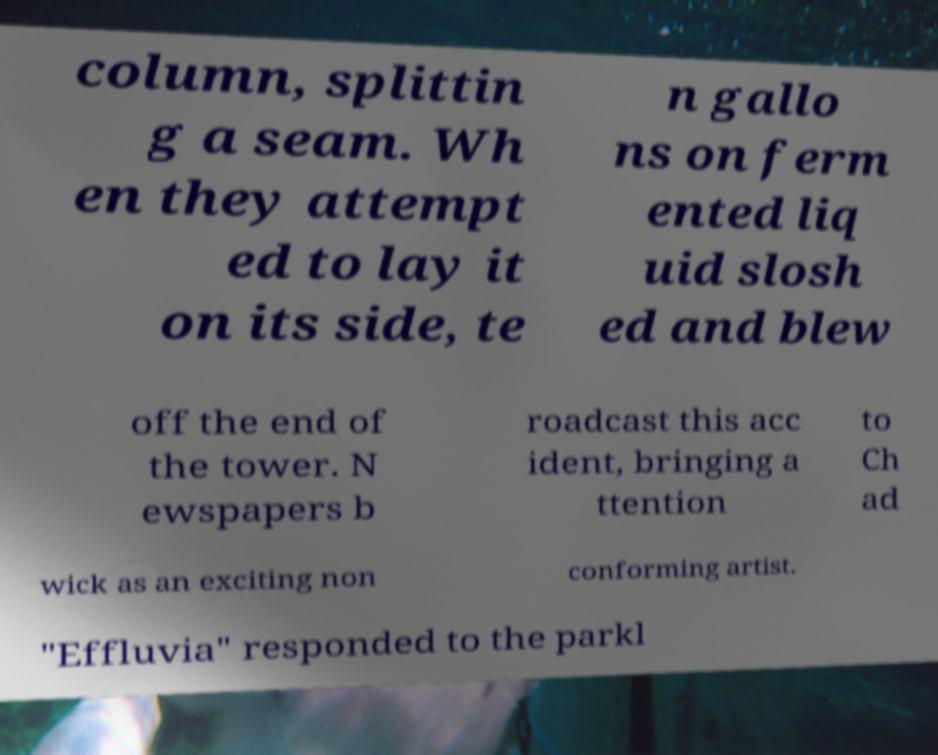Can you read and provide the text displayed in the image?This photo seems to have some interesting text. Can you extract and type it out for me? column, splittin g a seam. Wh en they attempt ed to lay it on its side, te n gallo ns on ferm ented liq uid slosh ed and blew off the end of the tower. N ewspapers b roadcast this acc ident, bringing a ttention to Ch ad wick as an exciting non conforming artist. "Effluvia" responded to the parkl 